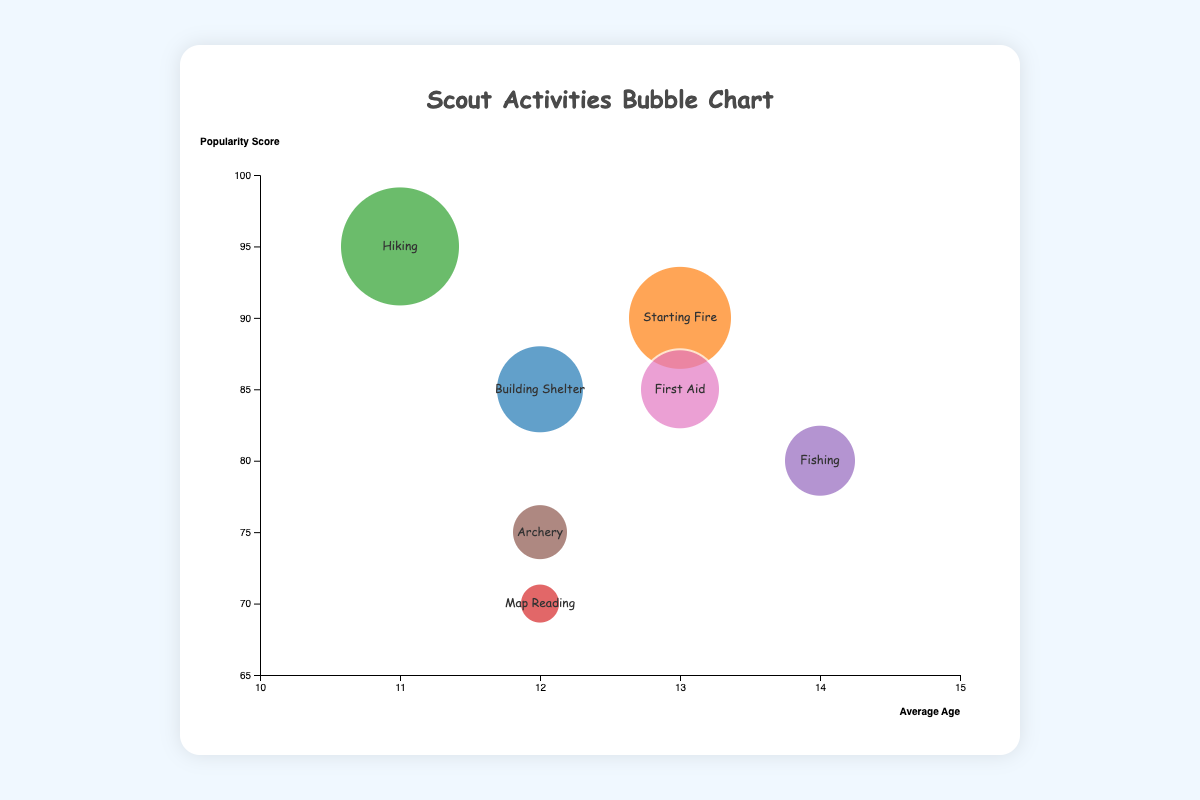What is the title of the chart? The title of the chart is usually displayed at the top and provides a summary of the chart's content. In this case, the title given is "Scout Activities Bubble Chart".
Answer: Scout Activities Bubble Chart How many different activities are shown in the chart? We can identify the different activities by looking at the distinct bubbles in the chart, each labeled with an activity's name. The chart shows "Building Shelter", "Starting Fire", "Hiking", "Map Reading", "Fishing", "Archery", and "First Aid", making it 7 activities in total.
Answer: 7 Which activity has the highest popularity score? By observing the y-axis values that represent the popularity score, we see that "Hiking" has the highest placement at a score of 95.
Answer: Hiking What is the average age associated with "Map Reading"? The average age for an activity can be identified by the position of the bubble along the x-axis. For "Map Reading", the bubble is positioned at an average age of 12.
Answer: 12 Which activity has the smallest bubble size? The bubble size can be evaluated by comparing the visible bubble sizes in the chart. "Map Reading" has the smallest bubble size of 120.
Answer: Map Reading Do "Building Shelter" and "First Aid" have the same popularity score? By comparing the y-axis positions of the bubbles for "Building Shelter" and "First Aid", we can see both are positioned at a popularity score of 85.
Answer: Yes Which activity is more popular, "Fishing" or "Archery"? To determine this, we compare the y-axis values of "Fishing" and "Archery". "Fishing" has a popularity score of 80, while "Archery" has a score of 75, making "Fishing" more popular.
Answer: Fishing What is the average of the popularity scores for all activities? Add up all the popularity scores (85, 90, 95, 70, 80, 75, 85) and then divide by the number of activities (7). (85 + 90 + 95 + 70 + 80 + 75 + 85) / 7 = 580 / 7 ≈ 82.857
Answer: Approximately 82.857 Which activity has the highest average age, and what is that age? By looking at the highest x-axis value, we see the bubble for "Fishing" is located at age 14, representing the highest average age.
Answer: Fishing, 14 